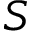Convert formula to latex. <formula><loc_0><loc_0><loc_500><loc_500>S</formula> 